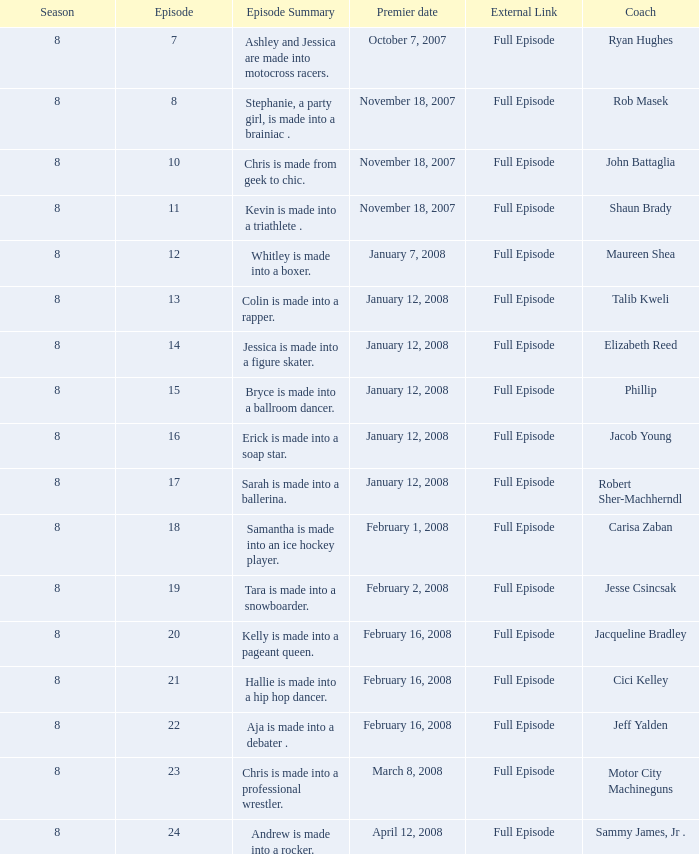What coach premiered February 16, 2008 later than episode 21.0? Jeff Yalden. 